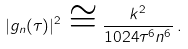<formula> <loc_0><loc_0><loc_500><loc_500>| g _ { n } ( \tau ) | ^ { 2 } \, \cong \frac { k ^ { 2 } } { 1 0 2 4 \tau ^ { 6 } n ^ { 6 } } \, .</formula> 